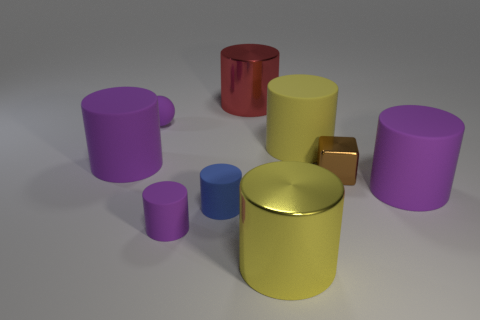There is a large cylinder in front of the tiny purple matte object that is in front of the metallic block to the right of the tiny blue thing; what is it made of?
Provide a succinct answer. Metal. Are the sphere and the brown object made of the same material?
Keep it short and to the point. No. There is a small rubber cylinder to the left of the small blue thing; is it the same color as the ball?
Ensure brevity in your answer.  Yes. How many cyan things are tiny things or tiny cylinders?
Give a very brief answer. 0. What is the color of the large cylinder on the left side of the small purple matte thing that is behind the small shiny object?
Provide a succinct answer. Purple. What is the material of the small cylinder that is the same color as the sphere?
Ensure brevity in your answer.  Rubber. There is a big cylinder that is on the left side of the big red object; what is its color?
Your response must be concise. Purple. There is a metallic cylinder in front of the yellow rubber object; is its size the same as the tiny metal object?
Your response must be concise. No. Is there another cylinder that has the same size as the blue cylinder?
Keep it short and to the point. Yes. There is a big matte object on the left side of the red shiny cylinder; is it the same color as the rubber object that is to the right of the small shiny object?
Make the answer very short. Yes. 